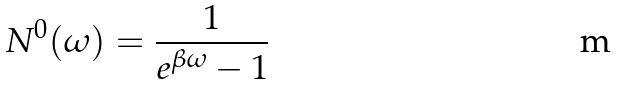Convert formula to latex. <formula><loc_0><loc_0><loc_500><loc_500>N ^ { 0 } ( \omega ) = \frac { 1 } { e ^ { \beta \omega } - 1 }</formula> 